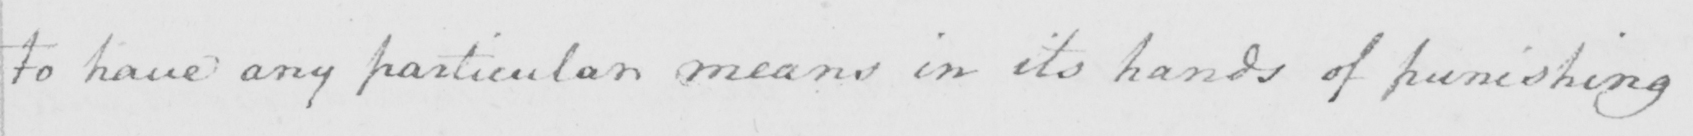Can you tell me what this handwritten text says? to have any particular means in its hands of punishing 